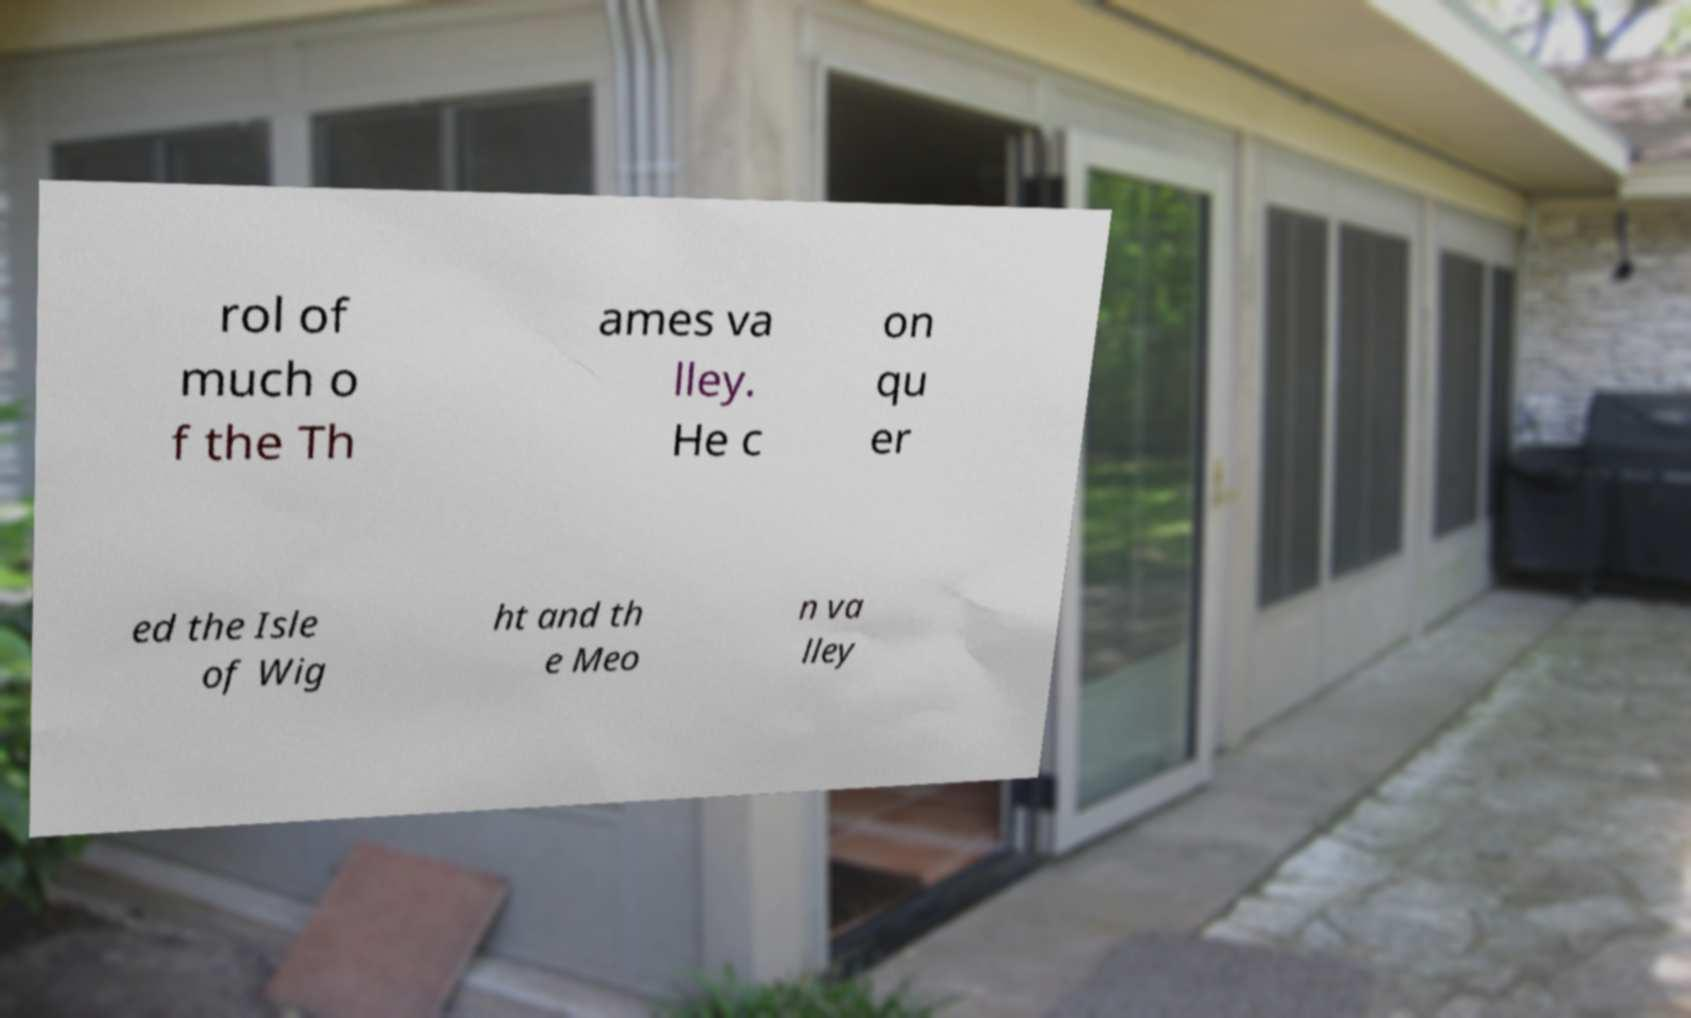There's text embedded in this image that I need extracted. Can you transcribe it verbatim? rol of much o f the Th ames va lley. He c on qu er ed the Isle of Wig ht and th e Meo n va lley 